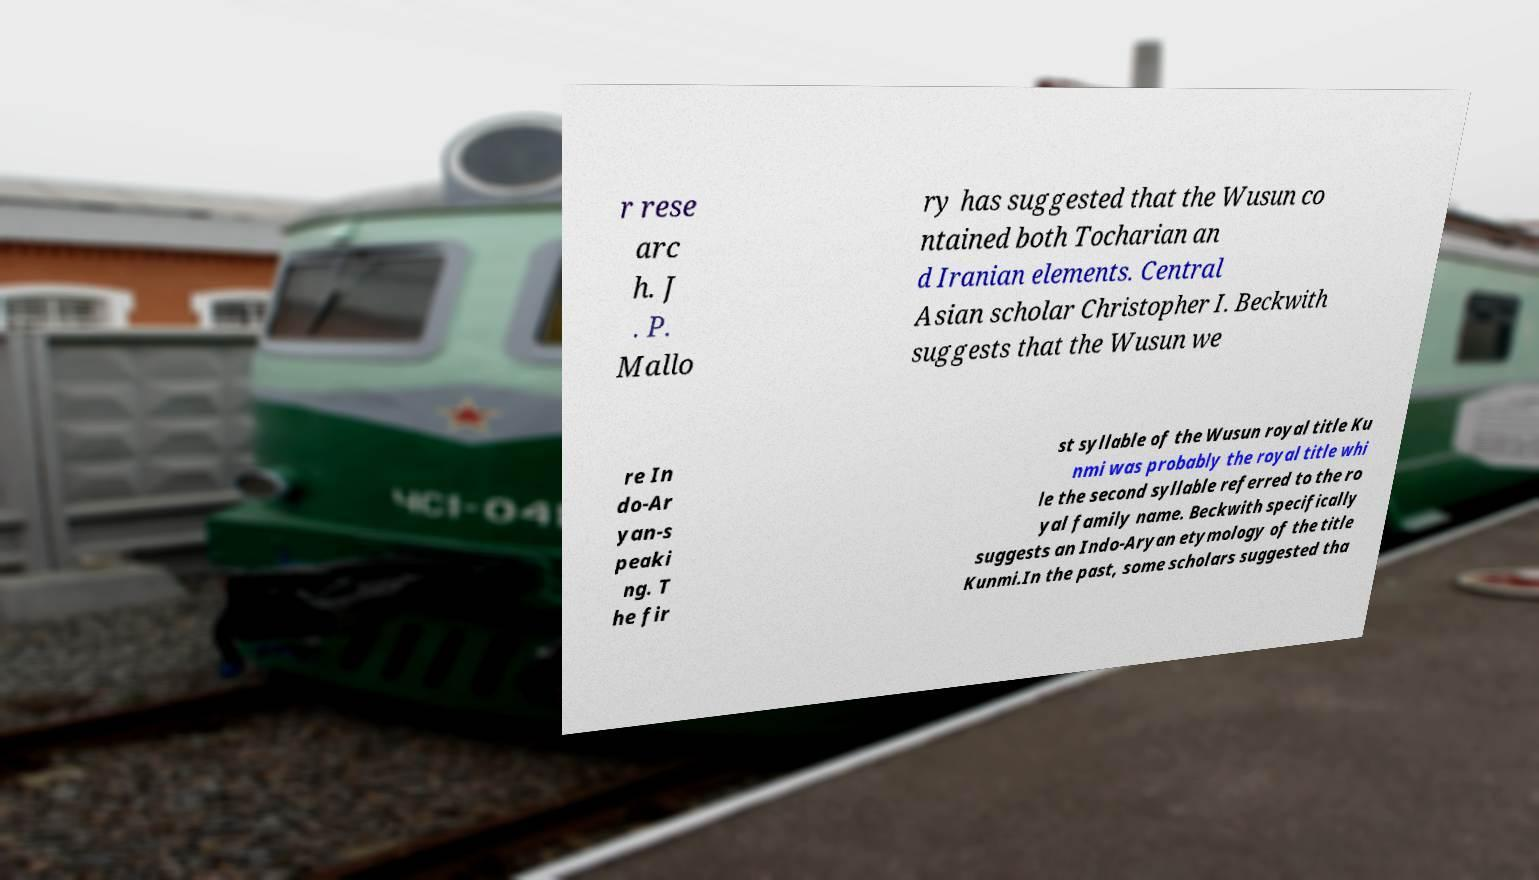There's text embedded in this image that I need extracted. Can you transcribe it verbatim? r rese arc h. J . P. Mallo ry has suggested that the Wusun co ntained both Tocharian an d Iranian elements. Central Asian scholar Christopher I. Beckwith suggests that the Wusun we re In do-Ar yan-s peaki ng. T he fir st syllable of the Wusun royal title Ku nmi was probably the royal title whi le the second syllable referred to the ro yal family name. Beckwith specifically suggests an Indo-Aryan etymology of the title Kunmi.In the past, some scholars suggested tha 